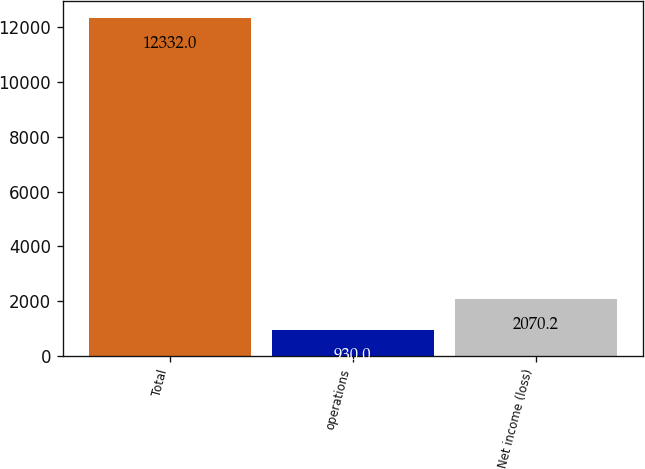<chart> <loc_0><loc_0><loc_500><loc_500><bar_chart><fcel>Total<fcel>operations<fcel>Net income (loss)<nl><fcel>12332<fcel>930<fcel>2070.2<nl></chart> 